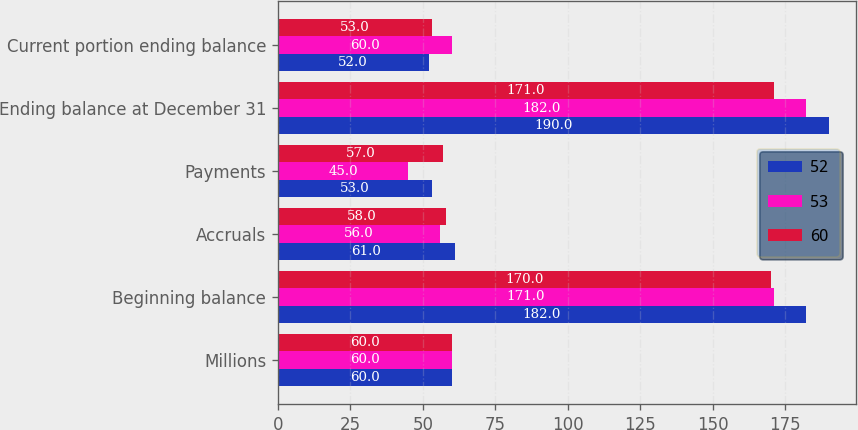<chart> <loc_0><loc_0><loc_500><loc_500><stacked_bar_chart><ecel><fcel>Millions<fcel>Beginning balance<fcel>Accruals<fcel>Payments<fcel>Ending balance at December 31<fcel>Current portion ending balance<nl><fcel>52<fcel>60<fcel>182<fcel>61<fcel>53<fcel>190<fcel>52<nl><fcel>53<fcel>60<fcel>171<fcel>56<fcel>45<fcel>182<fcel>60<nl><fcel>60<fcel>60<fcel>170<fcel>58<fcel>57<fcel>171<fcel>53<nl></chart> 